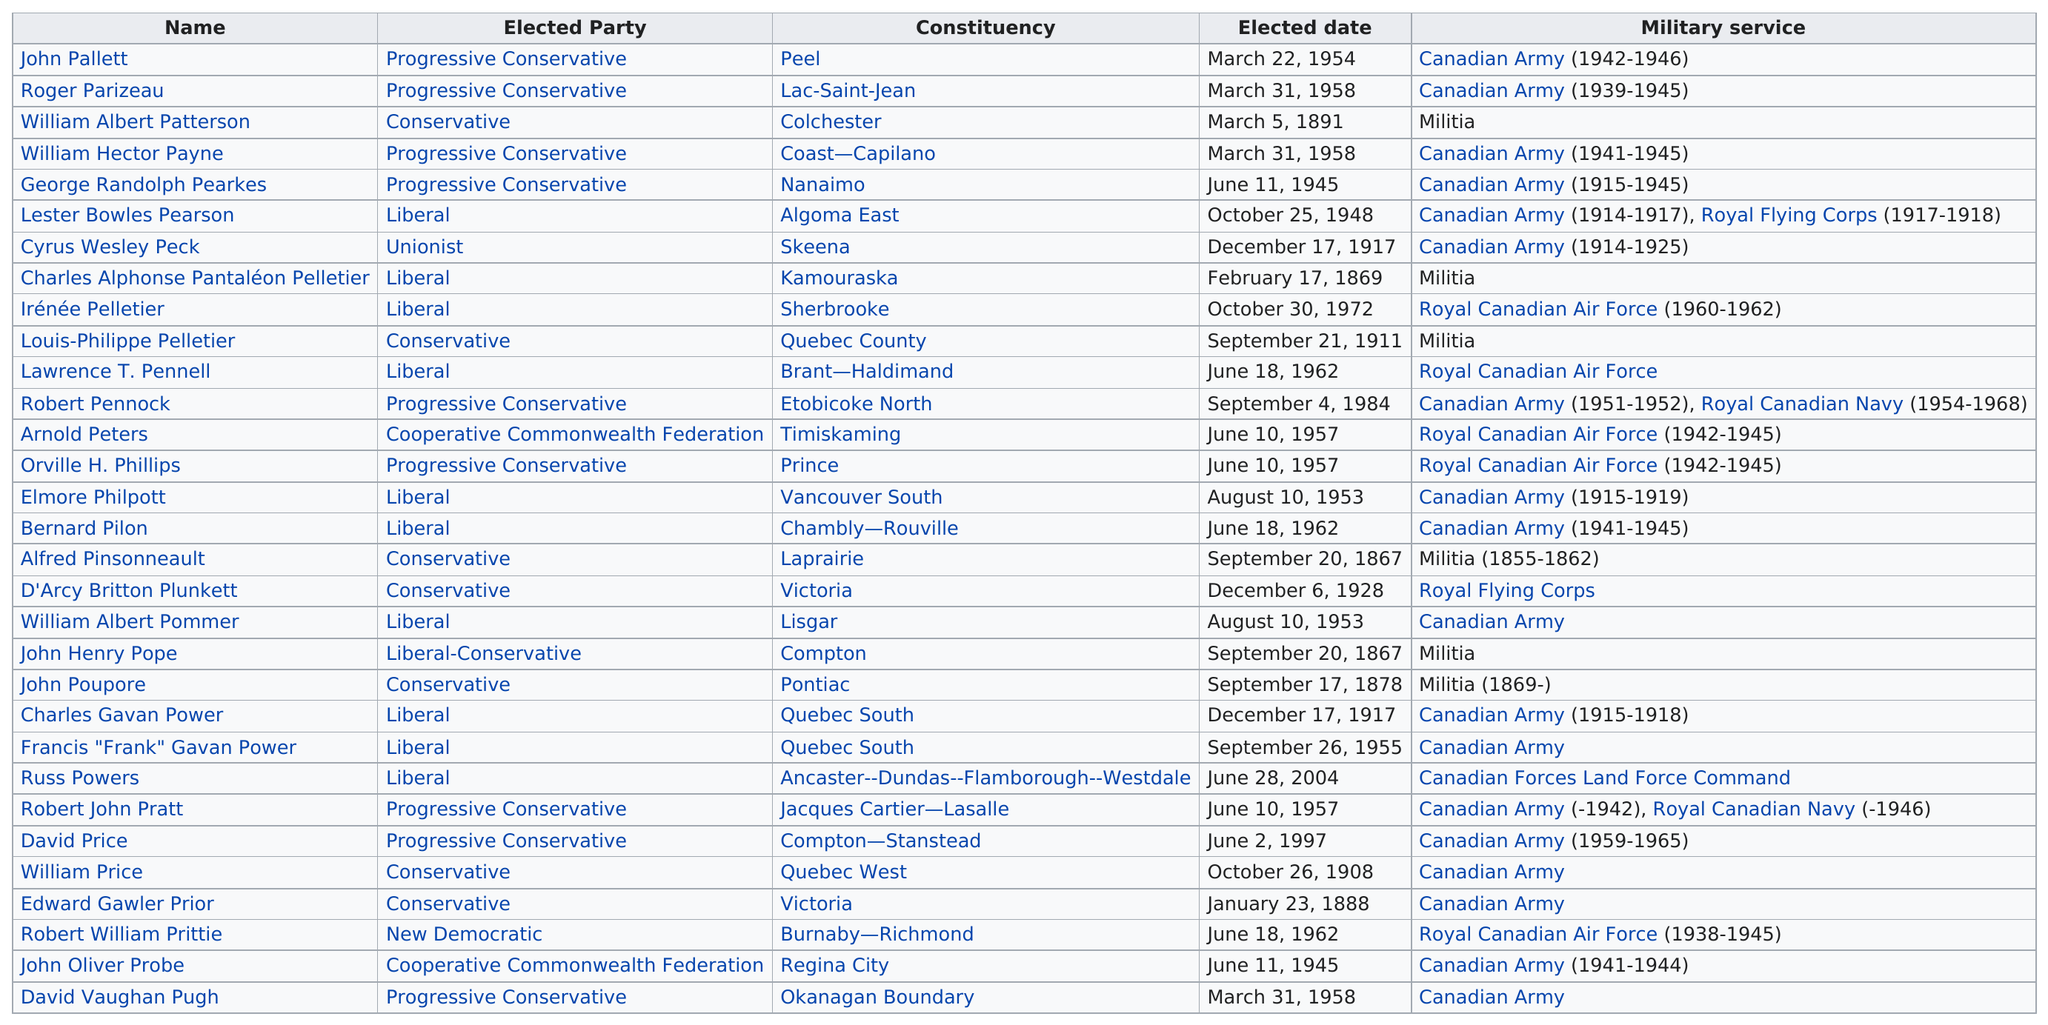Highlight a few significant elements in this photo. It is estimated that approximately 18 million people served in the Canadian Army. Six members of the Canadian House of Commons have served in the militia. The longest military career among Canadian House of Commons members spanned 30 years. The Royal Canadian Air Force has served a total of five members. Bernard Pilon served in the Canadian Army for a period of four years. 